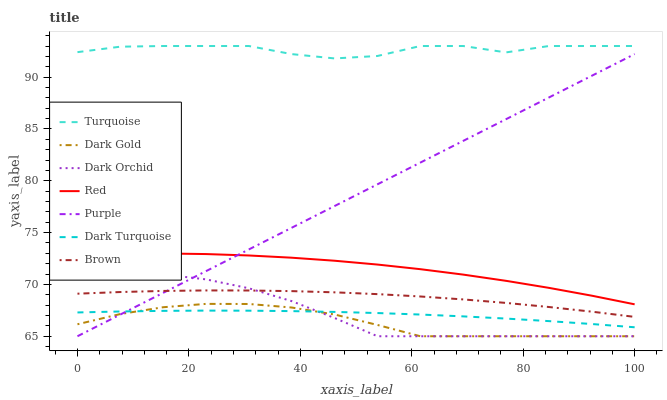Does Dark Gold have the minimum area under the curve?
Answer yes or no. Yes. Does Turquoise have the maximum area under the curve?
Answer yes or no. Yes. Does Turquoise have the minimum area under the curve?
Answer yes or no. No. Does Dark Gold have the maximum area under the curve?
Answer yes or no. No. Is Purple the smoothest?
Answer yes or no. Yes. Is Turquoise the roughest?
Answer yes or no. Yes. Is Dark Gold the smoothest?
Answer yes or no. No. Is Dark Gold the roughest?
Answer yes or no. No. Does Dark Gold have the lowest value?
Answer yes or no. Yes. Does Turquoise have the lowest value?
Answer yes or no. No. Does Turquoise have the highest value?
Answer yes or no. Yes. Does Dark Gold have the highest value?
Answer yes or no. No. Is Dark Orchid less than Red?
Answer yes or no. Yes. Is Turquoise greater than Purple?
Answer yes or no. Yes. Does Dark Turquoise intersect Dark Gold?
Answer yes or no. Yes. Is Dark Turquoise less than Dark Gold?
Answer yes or no. No. Is Dark Turquoise greater than Dark Gold?
Answer yes or no. No. Does Dark Orchid intersect Red?
Answer yes or no. No. 